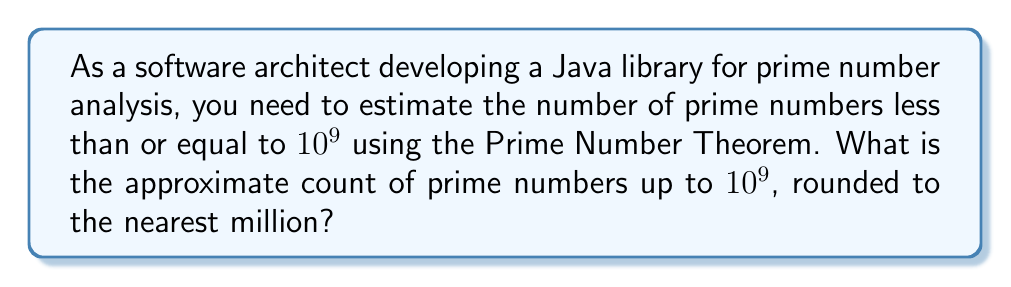Teach me how to tackle this problem. To solve this problem, we'll use the Prime Number Theorem (PNT) and follow these steps:

1. The Prime Number Theorem states that the number of primes less than or equal to x, denoted as π(x), is asymptotically equal to x / ln(x), where ln is the natural logarithm.

2. The approximation formula is:
   $$ \pi(x) \approx \frac{x}{\ln(x)} $$

3. In our case, x = 10^9, so we need to calculate:
   $$ \pi(10^9) \approx \frac{10^9}{\ln(10^9)} $$

4. Calculate ln(10^9):
   $$ \ln(10^9) = \ln(1000000000) \approx 20.7232658369 $$

5. Now, substitute this value into our approximation:
   $$ \pi(10^9) \approx \frac{10^9}{20.7232658369} \approx 48,254,942 $$

6. Rounding to the nearest million:
   48,254,942 ≈ 48,000,000

Therefore, the approximate count of prime numbers up to 10^9, rounded to the nearest million, is 48 million.

Note: The actual value of π(10^9) is 50,847,534, which shows that our approximation using PNT is quite accurate, with an error of about 5%.
Answer: 48 million 